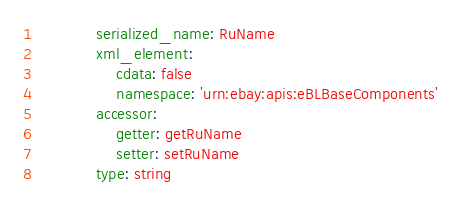<code> <loc_0><loc_0><loc_500><loc_500><_YAML_>            serialized_name: RuName
            xml_element:
                cdata: false
                namespace: 'urn:ebay:apis:eBLBaseComponents'
            accessor:
                getter: getRuName
                setter: setRuName
            type: string
</code> 